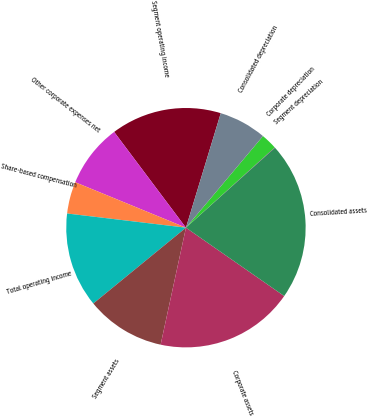Convert chart. <chart><loc_0><loc_0><loc_500><loc_500><pie_chart><fcel>Segment operating income<fcel>Other corporate expenses net<fcel>Share-based compensation<fcel>Total operating income<fcel>Segment assets<fcel>Corporate assets<fcel>Consolidated assets<fcel>Segment depreciation<fcel>Corporate depreciation<fcel>Consolidated depreciation<nl><fcel>14.94%<fcel>8.56%<fcel>4.31%<fcel>12.81%<fcel>10.69%<fcel>18.72%<fcel>21.32%<fcel>0.05%<fcel>2.18%<fcel>6.43%<nl></chart> 